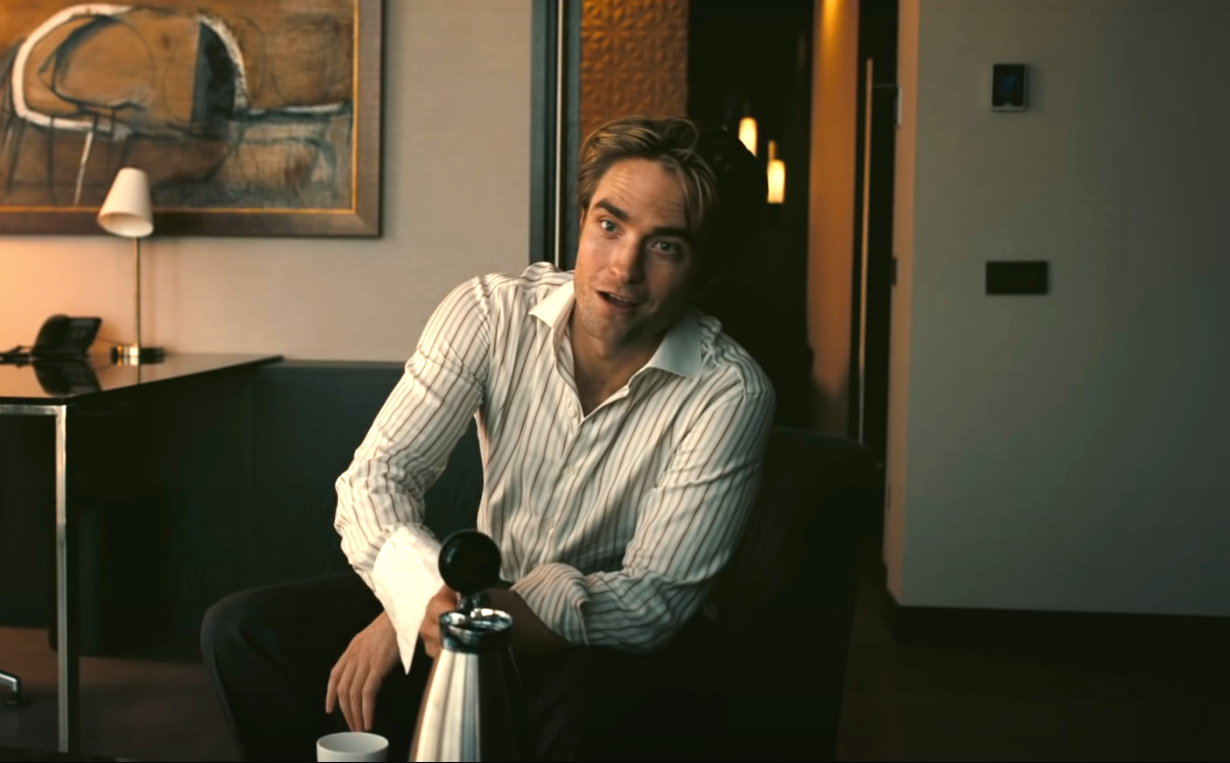What do you think the man is thinking about? The man's slight smile and distant gaze suggest he might be lost in a pleasant memory or deep in thought about a happy event or someone special. The relaxed atmosphere of the room and his comfortable posture enhance the sense that he is in a moment of peaceful reflection, perhaps thinking about a joyful past experience or feeling content with the present. 